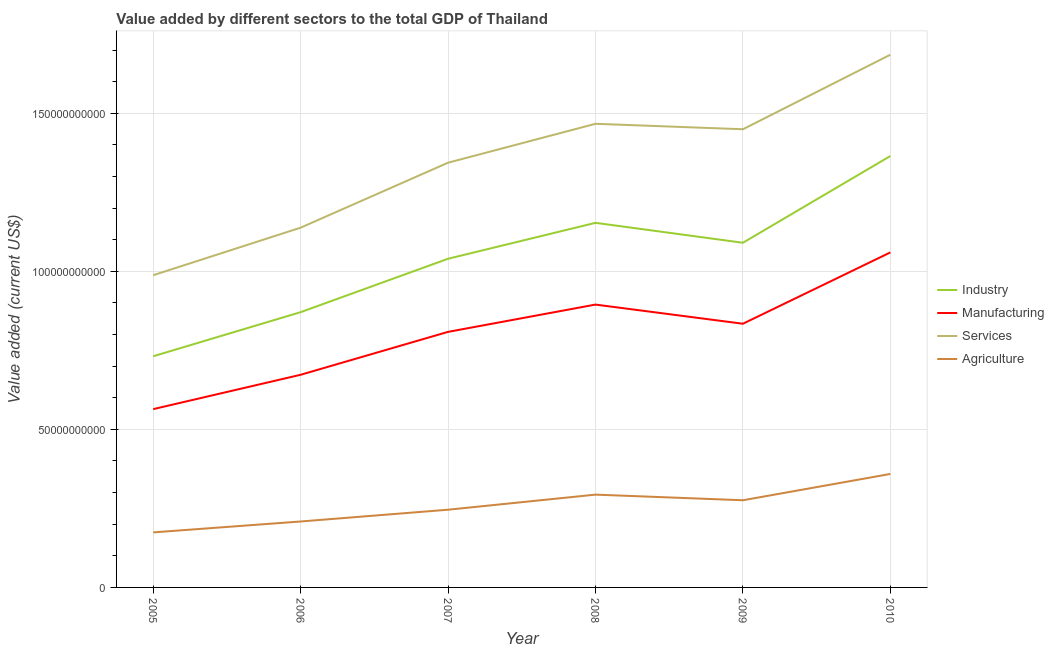How many different coloured lines are there?
Offer a very short reply. 4. Does the line corresponding to value added by industrial sector intersect with the line corresponding to value added by services sector?
Your answer should be compact. No. What is the value added by services sector in 2009?
Keep it short and to the point. 1.45e+11. Across all years, what is the maximum value added by industrial sector?
Give a very brief answer. 1.36e+11. Across all years, what is the minimum value added by industrial sector?
Provide a succinct answer. 7.31e+1. What is the total value added by services sector in the graph?
Your answer should be very brief. 8.07e+11. What is the difference between the value added by manufacturing sector in 2006 and that in 2008?
Provide a short and direct response. -2.22e+1. What is the difference between the value added by manufacturing sector in 2009 and the value added by industrial sector in 2007?
Provide a succinct answer. -2.06e+1. What is the average value added by industrial sector per year?
Provide a short and direct response. 1.04e+11. In the year 2008, what is the difference between the value added by agricultural sector and value added by services sector?
Ensure brevity in your answer.  -1.17e+11. What is the ratio of the value added by agricultural sector in 2006 to that in 2010?
Offer a terse response. 0.58. Is the value added by services sector in 2005 less than that in 2008?
Give a very brief answer. Yes. Is the difference between the value added by manufacturing sector in 2006 and 2010 greater than the difference between the value added by industrial sector in 2006 and 2010?
Your response must be concise. Yes. What is the difference between the highest and the second highest value added by manufacturing sector?
Give a very brief answer. 1.65e+1. What is the difference between the highest and the lowest value added by agricultural sector?
Offer a very short reply. 1.85e+1. Is it the case that in every year, the sum of the value added by services sector and value added by agricultural sector is greater than the sum of value added by manufacturing sector and value added by industrial sector?
Ensure brevity in your answer.  No. Is the value added by agricultural sector strictly less than the value added by services sector over the years?
Your answer should be compact. Yes. How many lines are there?
Ensure brevity in your answer.  4. How many years are there in the graph?
Provide a succinct answer. 6. Does the graph contain grids?
Provide a succinct answer. Yes. How many legend labels are there?
Make the answer very short. 4. How are the legend labels stacked?
Keep it short and to the point. Vertical. What is the title of the graph?
Your response must be concise. Value added by different sectors to the total GDP of Thailand. Does "Denmark" appear as one of the legend labels in the graph?
Your answer should be compact. No. What is the label or title of the X-axis?
Keep it short and to the point. Year. What is the label or title of the Y-axis?
Offer a very short reply. Value added (current US$). What is the Value added (current US$) in Industry in 2005?
Your answer should be compact. 7.31e+1. What is the Value added (current US$) of Manufacturing in 2005?
Your answer should be compact. 5.64e+1. What is the Value added (current US$) in Services in 2005?
Offer a very short reply. 9.88e+1. What is the Value added (current US$) in Agriculture in 2005?
Make the answer very short. 1.74e+1. What is the Value added (current US$) of Industry in 2006?
Offer a very short reply. 8.71e+1. What is the Value added (current US$) of Manufacturing in 2006?
Ensure brevity in your answer.  6.73e+1. What is the Value added (current US$) of Services in 2006?
Make the answer very short. 1.14e+11. What is the Value added (current US$) in Agriculture in 2006?
Offer a very short reply. 2.09e+1. What is the Value added (current US$) in Industry in 2007?
Offer a very short reply. 1.04e+11. What is the Value added (current US$) of Manufacturing in 2007?
Your response must be concise. 8.08e+1. What is the Value added (current US$) in Services in 2007?
Your response must be concise. 1.34e+11. What is the Value added (current US$) in Agriculture in 2007?
Offer a terse response. 2.46e+1. What is the Value added (current US$) in Industry in 2008?
Offer a very short reply. 1.15e+11. What is the Value added (current US$) of Manufacturing in 2008?
Your response must be concise. 8.95e+1. What is the Value added (current US$) in Services in 2008?
Give a very brief answer. 1.47e+11. What is the Value added (current US$) of Agriculture in 2008?
Offer a very short reply. 2.94e+1. What is the Value added (current US$) of Industry in 2009?
Provide a short and direct response. 1.09e+11. What is the Value added (current US$) of Manufacturing in 2009?
Make the answer very short. 8.34e+1. What is the Value added (current US$) in Services in 2009?
Offer a terse response. 1.45e+11. What is the Value added (current US$) of Agriculture in 2009?
Keep it short and to the point. 2.76e+1. What is the Value added (current US$) of Industry in 2010?
Offer a very short reply. 1.36e+11. What is the Value added (current US$) of Manufacturing in 2010?
Offer a very short reply. 1.06e+11. What is the Value added (current US$) in Services in 2010?
Your response must be concise. 1.69e+11. What is the Value added (current US$) of Agriculture in 2010?
Offer a terse response. 3.59e+1. Across all years, what is the maximum Value added (current US$) of Industry?
Offer a terse response. 1.36e+11. Across all years, what is the maximum Value added (current US$) in Manufacturing?
Provide a short and direct response. 1.06e+11. Across all years, what is the maximum Value added (current US$) in Services?
Offer a terse response. 1.69e+11. Across all years, what is the maximum Value added (current US$) in Agriculture?
Make the answer very short. 3.59e+1. Across all years, what is the minimum Value added (current US$) in Industry?
Provide a succinct answer. 7.31e+1. Across all years, what is the minimum Value added (current US$) of Manufacturing?
Keep it short and to the point. 5.64e+1. Across all years, what is the minimum Value added (current US$) in Services?
Keep it short and to the point. 9.88e+1. Across all years, what is the minimum Value added (current US$) of Agriculture?
Offer a terse response. 1.74e+1. What is the total Value added (current US$) in Industry in the graph?
Offer a very short reply. 6.25e+11. What is the total Value added (current US$) of Manufacturing in the graph?
Provide a short and direct response. 4.83e+11. What is the total Value added (current US$) of Services in the graph?
Your answer should be compact. 8.07e+11. What is the total Value added (current US$) in Agriculture in the graph?
Give a very brief answer. 1.56e+11. What is the difference between the Value added (current US$) of Industry in 2005 and that in 2006?
Offer a terse response. -1.40e+1. What is the difference between the Value added (current US$) of Manufacturing in 2005 and that in 2006?
Your answer should be very brief. -1.09e+1. What is the difference between the Value added (current US$) of Services in 2005 and that in 2006?
Keep it short and to the point. -1.50e+1. What is the difference between the Value added (current US$) in Agriculture in 2005 and that in 2006?
Provide a short and direct response. -3.45e+09. What is the difference between the Value added (current US$) of Industry in 2005 and that in 2007?
Offer a very short reply. -3.09e+1. What is the difference between the Value added (current US$) of Manufacturing in 2005 and that in 2007?
Ensure brevity in your answer.  -2.44e+1. What is the difference between the Value added (current US$) of Services in 2005 and that in 2007?
Your answer should be very brief. -3.56e+1. What is the difference between the Value added (current US$) of Agriculture in 2005 and that in 2007?
Your answer should be very brief. -7.17e+09. What is the difference between the Value added (current US$) of Industry in 2005 and that in 2008?
Ensure brevity in your answer.  -4.22e+1. What is the difference between the Value added (current US$) in Manufacturing in 2005 and that in 2008?
Your response must be concise. -3.31e+1. What is the difference between the Value added (current US$) in Services in 2005 and that in 2008?
Keep it short and to the point. -4.79e+1. What is the difference between the Value added (current US$) of Agriculture in 2005 and that in 2008?
Provide a short and direct response. -1.19e+1. What is the difference between the Value added (current US$) of Industry in 2005 and that in 2009?
Provide a short and direct response. -3.59e+1. What is the difference between the Value added (current US$) in Manufacturing in 2005 and that in 2009?
Keep it short and to the point. -2.70e+1. What is the difference between the Value added (current US$) of Services in 2005 and that in 2009?
Offer a very short reply. -4.62e+1. What is the difference between the Value added (current US$) in Agriculture in 2005 and that in 2009?
Provide a short and direct response. -1.02e+1. What is the difference between the Value added (current US$) of Industry in 2005 and that in 2010?
Offer a very short reply. -6.34e+1. What is the difference between the Value added (current US$) of Manufacturing in 2005 and that in 2010?
Ensure brevity in your answer.  -4.96e+1. What is the difference between the Value added (current US$) of Services in 2005 and that in 2010?
Keep it short and to the point. -6.98e+1. What is the difference between the Value added (current US$) in Agriculture in 2005 and that in 2010?
Provide a succinct answer. -1.85e+1. What is the difference between the Value added (current US$) in Industry in 2006 and that in 2007?
Give a very brief answer. -1.69e+1. What is the difference between the Value added (current US$) in Manufacturing in 2006 and that in 2007?
Your answer should be very brief. -1.36e+1. What is the difference between the Value added (current US$) in Services in 2006 and that in 2007?
Provide a short and direct response. -2.06e+1. What is the difference between the Value added (current US$) of Agriculture in 2006 and that in 2007?
Your answer should be very brief. -3.73e+09. What is the difference between the Value added (current US$) in Industry in 2006 and that in 2008?
Make the answer very short. -2.83e+1. What is the difference between the Value added (current US$) of Manufacturing in 2006 and that in 2008?
Your answer should be very brief. -2.22e+1. What is the difference between the Value added (current US$) of Services in 2006 and that in 2008?
Make the answer very short. -3.29e+1. What is the difference between the Value added (current US$) in Agriculture in 2006 and that in 2008?
Your answer should be compact. -8.50e+09. What is the difference between the Value added (current US$) of Industry in 2006 and that in 2009?
Make the answer very short. -2.20e+1. What is the difference between the Value added (current US$) in Manufacturing in 2006 and that in 2009?
Your answer should be very brief. -1.61e+1. What is the difference between the Value added (current US$) of Services in 2006 and that in 2009?
Make the answer very short. -3.11e+1. What is the difference between the Value added (current US$) of Agriculture in 2006 and that in 2009?
Keep it short and to the point. -6.72e+09. What is the difference between the Value added (current US$) in Industry in 2006 and that in 2010?
Your answer should be very brief. -4.94e+1. What is the difference between the Value added (current US$) in Manufacturing in 2006 and that in 2010?
Offer a terse response. -3.87e+1. What is the difference between the Value added (current US$) of Services in 2006 and that in 2010?
Your answer should be very brief. -5.47e+1. What is the difference between the Value added (current US$) in Agriculture in 2006 and that in 2010?
Provide a short and direct response. -1.50e+1. What is the difference between the Value added (current US$) in Industry in 2007 and that in 2008?
Your answer should be very brief. -1.14e+1. What is the difference between the Value added (current US$) of Manufacturing in 2007 and that in 2008?
Make the answer very short. -8.63e+09. What is the difference between the Value added (current US$) of Services in 2007 and that in 2008?
Your answer should be compact. -1.23e+1. What is the difference between the Value added (current US$) in Agriculture in 2007 and that in 2008?
Make the answer very short. -4.77e+09. What is the difference between the Value added (current US$) in Industry in 2007 and that in 2009?
Make the answer very short. -5.06e+09. What is the difference between the Value added (current US$) in Manufacturing in 2007 and that in 2009?
Make the answer very short. -2.57e+09. What is the difference between the Value added (current US$) in Services in 2007 and that in 2009?
Your answer should be very brief. -1.06e+1. What is the difference between the Value added (current US$) of Agriculture in 2007 and that in 2009?
Offer a very short reply. -2.99e+09. What is the difference between the Value added (current US$) in Industry in 2007 and that in 2010?
Your answer should be compact. -3.25e+1. What is the difference between the Value added (current US$) of Manufacturing in 2007 and that in 2010?
Your answer should be very brief. -2.51e+1. What is the difference between the Value added (current US$) of Services in 2007 and that in 2010?
Your response must be concise. -3.42e+1. What is the difference between the Value added (current US$) of Agriculture in 2007 and that in 2010?
Your answer should be compact. -1.13e+1. What is the difference between the Value added (current US$) in Industry in 2008 and that in 2009?
Ensure brevity in your answer.  6.30e+09. What is the difference between the Value added (current US$) in Manufacturing in 2008 and that in 2009?
Give a very brief answer. 6.06e+09. What is the difference between the Value added (current US$) of Services in 2008 and that in 2009?
Give a very brief answer. 1.73e+09. What is the difference between the Value added (current US$) in Agriculture in 2008 and that in 2009?
Make the answer very short. 1.78e+09. What is the difference between the Value added (current US$) of Industry in 2008 and that in 2010?
Make the answer very short. -2.11e+1. What is the difference between the Value added (current US$) in Manufacturing in 2008 and that in 2010?
Give a very brief answer. -1.65e+1. What is the difference between the Value added (current US$) in Services in 2008 and that in 2010?
Ensure brevity in your answer.  -2.19e+1. What is the difference between the Value added (current US$) of Agriculture in 2008 and that in 2010?
Offer a very short reply. -6.54e+09. What is the difference between the Value added (current US$) in Industry in 2009 and that in 2010?
Your answer should be very brief. -2.74e+1. What is the difference between the Value added (current US$) of Manufacturing in 2009 and that in 2010?
Make the answer very short. -2.26e+1. What is the difference between the Value added (current US$) in Services in 2009 and that in 2010?
Make the answer very short. -2.36e+1. What is the difference between the Value added (current US$) of Agriculture in 2009 and that in 2010?
Make the answer very short. -8.32e+09. What is the difference between the Value added (current US$) in Industry in 2005 and the Value added (current US$) in Manufacturing in 2006?
Your answer should be compact. 5.86e+09. What is the difference between the Value added (current US$) of Industry in 2005 and the Value added (current US$) of Services in 2006?
Keep it short and to the point. -4.07e+1. What is the difference between the Value added (current US$) of Industry in 2005 and the Value added (current US$) of Agriculture in 2006?
Provide a succinct answer. 5.23e+1. What is the difference between the Value added (current US$) in Manufacturing in 2005 and the Value added (current US$) in Services in 2006?
Provide a succinct answer. -5.74e+1. What is the difference between the Value added (current US$) of Manufacturing in 2005 and the Value added (current US$) of Agriculture in 2006?
Ensure brevity in your answer.  3.55e+1. What is the difference between the Value added (current US$) in Services in 2005 and the Value added (current US$) in Agriculture in 2006?
Offer a very short reply. 7.79e+1. What is the difference between the Value added (current US$) of Industry in 2005 and the Value added (current US$) of Manufacturing in 2007?
Give a very brief answer. -7.72e+09. What is the difference between the Value added (current US$) in Industry in 2005 and the Value added (current US$) in Services in 2007?
Provide a succinct answer. -6.12e+1. What is the difference between the Value added (current US$) in Industry in 2005 and the Value added (current US$) in Agriculture in 2007?
Offer a terse response. 4.85e+1. What is the difference between the Value added (current US$) in Manufacturing in 2005 and the Value added (current US$) in Services in 2007?
Make the answer very short. -7.80e+1. What is the difference between the Value added (current US$) of Manufacturing in 2005 and the Value added (current US$) of Agriculture in 2007?
Keep it short and to the point. 3.18e+1. What is the difference between the Value added (current US$) in Services in 2005 and the Value added (current US$) in Agriculture in 2007?
Make the answer very short. 7.42e+1. What is the difference between the Value added (current US$) in Industry in 2005 and the Value added (current US$) in Manufacturing in 2008?
Provide a short and direct response. -1.64e+1. What is the difference between the Value added (current US$) of Industry in 2005 and the Value added (current US$) of Services in 2008?
Your response must be concise. -7.35e+1. What is the difference between the Value added (current US$) of Industry in 2005 and the Value added (current US$) of Agriculture in 2008?
Your response must be concise. 4.38e+1. What is the difference between the Value added (current US$) in Manufacturing in 2005 and the Value added (current US$) in Services in 2008?
Provide a short and direct response. -9.03e+1. What is the difference between the Value added (current US$) in Manufacturing in 2005 and the Value added (current US$) in Agriculture in 2008?
Your answer should be very brief. 2.70e+1. What is the difference between the Value added (current US$) of Services in 2005 and the Value added (current US$) of Agriculture in 2008?
Provide a short and direct response. 6.94e+1. What is the difference between the Value added (current US$) in Industry in 2005 and the Value added (current US$) in Manufacturing in 2009?
Give a very brief answer. -1.03e+1. What is the difference between the Value added (current US$) in Industry in 2005 and the Value added (current US$) in Services in 2009?
Your response must be concise. -7.18e+1. What is the difference between the Value added (current US$) of Industry in 2005 and the Value added (current US$) of Agriculture in 2009?
Ensure brevity in your answer.  4.56e+1. What is the difference between the Value added (current US$) of Manufacturing in 2005 and the Value added (current US$) of Services in 2009?
Provide a short and direct response. -8.85e+1. What is the difference between the Value added (current US$) in Manufacturing in 2005 and the Value added (current US$) in Agriculture in 2009?
Keep it short and to the point. 2.88e+1. What is the difference between the Value added (current US$) of Services in 2005 and the Value added (current US$) of Agriculture in 2009?
Your response must be concise. 7.12e+1. What is the difference between the Value added (current US$) in Industry in 2005 and the Value added (current US$) in Manufacturing in 2010?
Keep it short and to the point. -3.29e+1. What is the difference between the Value added (current US$) in Industry in 2005 and the Value added (current US$) in Services in 2010?
Offer a terse response. -9.54e+1. What is the difference between the Value added (current US$) in Industry in 2005 and the Value added (current US$) in Agriculture in 2010?
Keep it short and to the point. 3.72e+1. What is the difference between the Value added (current US$) in Manufacturing in 2005 and the Value added (current US$) in Services in 2010?
Offer a very short reply. -1.12e+11. What is the difference between the Value added (current US$) in Manufacturing in 2005 and the Value added (current US$) in Agriculture in 2010?
Offer a very short reply. 2.05e+1. What is the difference between the Value added (current US$) in Services in 2005 and the Value added (current US$) in Agriculture in 2010?
Your answer should be compact. 6.29e+1. What is the difference between the Value added (current US$) in Industry in 2006 and the Value added (current US$) in Manufacturing in 2007?
Ensure brevity in your answer.  6.23e+09. What is the difference between the Value added (current US$) in Industry in 2006 and the Value added (current US$) in Services in 2007?
Offer a terse response. -4.73e+1. What is the difference between the Value added (current US$) in Industry in 2006 and the Value added (current US$) in Agriculture in 2007?
Provide a short and direct response. 6.25e+1. What is the difference between the Value added (current US$) of Manufacturing in 2006 and the Value added (current US$) of Services in 2007?
Ensure brevity in your answer.  -6.71e+1. What is the difference between the Value added (current US$) in Manufacturing in 2006 and the Value added (current US$) in Agriculture in 2007?
Provide a succinct answer. 4.27e+1. What is the difference between the Value added (current US$) of Services in 2006 and the Value added (current US$) of Agriculture in 2007?
Provide a short and direct response. 8.92e+1. What is the difference between the Value added (current US$) of Industry in 2006 and the Value added (current US$) of Manufacturing in 2008?
Provide a succinct answer. -2.40e+09. What is the difference between the Value added (current US$) of Industry in 2006 and the Value added (current US$) of Services in 2008?
Your answer should be very brief. -5.96e+1. What is the difference between the Value added (current US$) in Industry in 2006 and the Value added (current US$) in Agriculture in 2008?
Provide a succinct answer. 5.77e+1. What is the difference between the Value added (current US$) of Manufacturing in 2006 and the Value added (current US$) of Services in 2008?
Your answer should be compact. -7.94e+1. What is the difference between the Value added (current US$) in Manufacturing in 2006 and the Value added (current US$) in Agriculture in 2008?
Offer a very short reply. 3.79e+1. What is the difference between the Value added (current US$) in Services in 2006 and the Value added (current US$) in Agriculture in 2008?
Ensure brevity in your answer.  8.45e+1. What is the difference between the Value added (current US$) in Industry in 2006 and the Value added (current US$) in Manufacturing in 2009?
Ensure brevity in your answer.  3.66e+09. What is the difference between the Value added (current US$) of Industry in 2006 and the Value added (current US$) of Services in 2009?
Your response must be concise. -5.79e+1. What is the difference between the Value added (current US$) of Industry in 2006 and the Value added (current US$) of Agriculture in 2009?
Make the answer very short. 5.95e+1. What is the difference between the Value added (current US$) in Manufacturing in 2006 and the Value added (current US$) in Services in 2009?
Make the answer very short. -7.77e+1. What is the difference between the Value added (current US$) of Manufacturing in 2006 and the Value added (current US$) of Agriculture in 2009?
Your answer should be compact. 3.97e+1. What is the difference between the Value added (current US$) in Services in 2006 and the Value added (current US$) in Agriculture in 2009?
Make the answer very short. 8.62e+1. What is the difference between the Value added (current US$) of Industry in 2006 and the Value added (current US$) of Manufacturing in 2010?
Make the answer very short. -1.89e+1. What is the difference between the Value added (current US$) of Industry in 2006 and the Value added (current US$) of Services in 2010?
Ensure brevity in your answer.  -8.15e+1. What is the difference between the Value added (current US$) in Industry in 2006 and the Value added (current US$) in Agriculture in 2010?
Your response must be concise. 5.12e+1. What is the difference between the Value added (current US$) in Manufacturing in 2006 and the Value added (current US$) in Services in 2010?
Your answer should be compact. -1.01e+11. What is the difference between the Value added (current US$) in Manufacturing in 2006 and the Value added (current US$) in Agriculture in 2010?
Offer a terse response. 3.14e+1. What is the difference between the Value added (current US$) in Services in 2006 and the Value added (current US$) in Agriculture in 2010?
Provide a succinct answer. 7.79e+1. What is the difference between the Value added (current US$) of Industry in 2007 and the Value added (current US$) of Manufacturing in 2008?
Offer a very short reply. 1.45e+1. What is the difference between the Value added (current US$) in Industry in 2007 and the Value added (current US$) in Services in 2008?
Your answer should be compact. -4.27e+1. What is the difference between the Value added (current US$) in Industry in 2007 and the Value added (current US$) in Agriculture in 2008?
Give a very brief answer. 7.46e+1. What is the difference between the Value added (current US$) of Manufacturing in 2007 and the Value added (current US$) of Services in 2008?
Your answer should be compact. -6.58e+1. What is the difference between the Value added (current US$) in Manufacturing in 2007 and the Value added (current US$) in Agriculture in 2008?
Provide a short and direct response. 5.15e+1. What is the difference between the Value added (current US$) of Services in 2007 and the Value added (current US$) of Agriculture in 2008?
Give a very brief answer. 1.05e+11. What is the difference between the Value added (current US$) in Industry in 2007 and the Value added (current US$) in Manufacturing in 2009?
Make the answer very short. 2.06e+1. What is the difference between the Value added (current US$) of Industry in 2007 and the Value added (current US$) of Services in 2009?
Provide a short and direct response. -4.10e+1. What is the difference between the Value added (current US$) of Industry in 2007 and the Value added (current US$) of Agriculture in 2009?
Make the answer very short. 7.64e+1. What is the difference between the Value added (current US$) of Manufacturing in 2007 and the Value added (current US$) of Services in 2009?
Provide a short and direct response. -6.41e+1. What is the difference between the Value added (current US$) of Manufacturing in 2007 and the Value added (current US$) of Agriculture in 2009?
Your answer should be compact. 5.33e+1. What is the difference between the Value added (current US$) of Services in 2007 and the Value added (current US$) of Agriculture in 2009?
Offer a very short reply. 1.07e+11. What is the difference between the Value added (current US$) in Industry in 2007 and the Value added (current US$) in Manufacturing in 2010?
Give a very brief answer. -2.00e+09. What is the difference between the Value added (current US$) in Industry in 2007 and the Value added (current US$) in Services in 2010?
Provide a succinct answer. -6.46e+1. What is the difference between the Value added (current US$) in Industry in 2007 and the Value added (current US$) in Agriculture in 2010?
Keep it short and to the point. 6.81e+1. What is the difference between the Value added (current US$) of Manufacturing in 2007 and the Value added (current US$) of Services in 2010?
Provide a short and direct response. -8.77e+1. What is the difference between the Value added (current US$) in Manufacturing in 2007 and the Value added (current US$) in Agriculture in 2010?
Ensure brevity in your answer.  4.49e+1. What is the difference between the Value added (current US$) in Services in 2007 and the Value added (current US$) in Agriculture in 2010?
Give a very brief answer. 9.85e+1. What is the difference between the Value added (current US$) in Industry in 2008 and the Value added (current US$) in Manufacturing in 2009?
Offer a terse response. 3.19e+1. What is the difference between the Value added (current US$) in Industry in 2008 and the Value added (current US$) in Services in 2009?
Provide a succinct answer. -2.96e+1. What is the difference between the Value added (current US$) in Industry in 2008 and the Value added (current US$) in Agriculture in 2009?
Your response must be concise. 8.78e+1. What is the difference between the Value added (current US$) in Manufacturing in 2008 and the Value added (current US$) in Services in 2009?
Offer a very short reply. -5.55e+1. What is the difference between the Value added (current US$) of Manufacturing in 2008 and the Value added (current US$) of Agriculture in 2009?
Offer a terse response. 6.19e+1. What is the difference between the Value added (current US$) of Services in 2008 and the Value added (current US$) of Agriculture in 2009?
Offer a very short reply. 1.19e+11. What is the difference between the Value added (current US$) of Industry in 2008 and the Value added (current US$) of Manufacturing in 2010?
Your response must be concise. 9.36e+09. What is the difference between the Value added (current US$) of Industry in 2008 and the Value added (current US$) of Services in 2010?
Offer a terse response. -5.32e+1. What is the difference between the Value added (current US$) of Industry in 2008 and the Value added (current US$) of Agriculture in 2010?
Your answer should be very brief. 7.94e+1. What is the difference between the Value added (current US$) in Manufacturing in 2008 and the Value added (current US$) in Services in 2010?
Provide a succinct answer. -7.91e+1. What is the difference between the Value added (current US$) of Manufacturing in 2008 and the Value added (current US$) of Agriculture in 2010?
Ensure brevity in your answer.  5.36e+1. What is the difference between the Value added (current US$) in Services in 2008 and the Value added (current US$) in Agriculture in 2010?
Provide a short and direct response. 1.11e+11. What is the difference between the Value added (current US$) in Industry in 2009 and the Value added (current US$) in Manufacturing in 2010?
Provide a short and direct response. 3.06e+09. What is the difference between the Value added (current US$) of Industry in 2009 and the Value added (current US$) of Services in 2010?
Make the answer very short. -5.95e+1. What is the difference between the Value added (current US$) of Industry in 2009 and the Value added (current US$) of Agriculture in 2010?
Provide a short and direct response. 7.31e+1. What is the difference between the Value added (current US$) of Manufacturing in 2009 and the Value added (current US$) of Services in 2010?
Keep it short and to the point. -8.51e+1. What is the difference between the Value added (current US$) of Manufacturing in 2009 and the Value added (current US$) of Agriculture in 2010?
Keep it short and to the point. 4.75e+1. What is the difference between the Value added (current US$) in Services in 2009 and the Value added (current US$) in Agriculture in 2010?
Provide a succinct answer. 1.09e+11. What is the average Value added (current US$) of Industry per year?
Your response must be concise. 1.04e+11. What is the average Value added (current US$) of Manufacturing per year?
Your answer should be very brief. 8.06e+1. What is the average Value added (current US$) of Services per year?
Give a very brief answer. 1.35e+11. What is the average Value added (current US$) of Agriculture per year?
Provide a succinct answer. 2.59e+1. In the year 2005, what is the difference between the Value added (current US$) of Industry and Value added (current US$) of Manufacturing?
Your response must be concise. 1.67e+1. In the year 2005, what is the difference between the Value added (current US$) in Industry and Value added (current US$) in Services?
Provide a succinct answer. -2.56e+1. In the year 2005, what is the difference between the Value added (current US$) of Industry and Value added (current US$) of Agriculture?
Offer a very short reply. 5.57e+1. In the year 2005, what is the difference between the Value added (current US$) of Manufacturing and Value added (current US$) of Services?
Offer a very short reply. -4.24e+1. In the year 2005, what is the difference between the Value added (current US$) in Manufacturing and Value added (current US$) in Agriculture?
Provide a succinct answer. 3.90e+1. In the year 2005, what is the difference between the Value added (current US$) in Services and Value added (current US$) in Agriculture?
Your answer should be very brief. 8.14e+1. In the year 2006, what is the difference between the Value added (current US$) of Industry and Value added (current US$) of Manufacturing?
Give a very brief answer. 1.98e+1. In the year 2006, what is the difference between the Value added (current US$) of Industry and Value added (current US$) of Services?
Keep it short and to the point. -2.67e+1. In the year 2006, what is the difference between the Value added (current US$) of Industry and Value added (current US$) of Agriculture?
Your answer should be compact. 6.62e+1. In the year 2006, what is the difference between the Value added (current US$) of Manufacturing and Value added (current US$) of Services?
Give a very brief answer. -4.65e+1. In the year 2006, what is the difference between the Value added (current US$) of Manufacturing and Value added (current US$) of Agriculture?
Ensure brevity in your answer.  4.64e+1. In the year 2006, what is the difference between the Value added (current US$) in Services and Value added (current US$) in Agriculture?
Ensure brevity in your answer.  9.30e+1. In the year 2007, what is the difference between the Value added (current US$) in Industry and Value added (current US$) in Manufacturing?
Offer a terse response. 2.31e+1. In the year 2007, what is the difference between the Value added (current US$) of Industry and Value added (current US$) of Services?
Offer a terse response. -3.04e+1. In the year 2007, what is the difference between the Value added (current US$) in Industry and Value added (current US$) in Agriculture?
Make the answer very short. 7.94e+1. In the year 2007, what is the difference between the Value added (current US$) of Manufacturing and Value added (current US$) of Services?
Your answer should be very brief. -5.35e+1. In the year 2007, what is the difference between the Value added (current US$) of Manufacturing and Value added (current US$) of Agriculture?
Your answer should be compact. 5.63e+1. In the year 2007, what is the difference between the Value added (current US$) in Services and Value added (current US$) in Agriculture?
Ensure brevity in your answer.  1.10e+11. In the year 2008, what is the difference between the Value added (current US$) of Industry and Value added (current US$) of Manufacturing?
Keep it short and to the point. 2.59e+1. In the year 2008, what is the difference between the Value added (current US$) in Industry and Value added (current US$) in Services?
Your answer should be very brief. -3.13e+1. In the year 2008, what is the difference between the Value added (current US$) in Industry and Value added (current US$) in Agriculture?
Your answer should be very brief. 8.60e+1. In the year 2008, what is the difference between the Value added (current US$) in Manufacturing and Value added (current US$) in Services?
Your response must be concise. -5.72e+1. In the year 2008, what is the difference between the Value added (current US$) of Manufacturing and Value added (current US$) of Agriculture?
Ensure brevity in your answer.  6.01e+1. In the year 2008, what is the difference between the Value added (current US$) of Services and Value added (current US$) of Agriculture?
Make the answer very short. 1.17e+11. In the year 2009, what is the difference between the Value added (current US$) of Industry and Value added (current US$) of Manufacturing?
Your answer should be compact. 2.56e+1. In the year 2009, what is the difference between the Value added (current US$) in Industry and Value added (current US$) in Services?
Offer a very short reply. -3.59e+1. In the year 2009, what is the difference between the Value added (current US$) in Industry and Value added (current US$) in Agriculture?
Your response must be concise. 8.15e+1. In the year 2009, what is the difference between the Value added (current US$) in Manufacturing and Value added (current US$) in Services?
Offer a terse response. -6.15e+1. In the year 2009, what is the difference between the Value added (current US$) of Manufacturing and Value added (current US$) of Agriculture?
Your answer should be compact. 5.58e+1. In the year 2009, what is the difference between the Value added (current US$) in Services and Value added (current US$) in Agriculture?
Provide a succinct answer. 1.17e+11. In the year 2010, what is the difference between the Value added (current US$) in Industry and Value added (current US$) in Manufacturing?
Provide a short and direct response. 3.05e+1. In the year 2010, what is the difference between the Value added (current US$) in Industry and Value added (current US$) in Services?
Ensure brevity in your answer.  -3.21e+1. In the year 2010, what is the difference between the Value added (current US$) of Industry and Value added (current US$) of Agriculture?
Provide a short and direct response. 1.01e+11. In the year 2010, what is the difference between the Value added (current US$) in Manufacturing and Value added (current US$) in Services?
Offer a very short reply. -6.25e+1. In the year 2010, what is the difference between the Value added (current US$) in Manufacturing and Value added (current US$) in Agriculture?
Ensure brevity in your answer.  7.01e+1. In the year 2010, what is the difference between the Value added (current US$) of Services and Value added (current US$) of Agriculture?
Keep it short and to the point. 1.33e+11. What is the ratio of the Value added (current US$) in Industry in 2005 to that in 2006?
Your answer should be compact. 0.84. What is the ratio of the Value added (current US$) of Manufacturing in 2005 to that in 2006?
Give a very brief answer. 0.84. What is the ratio of the Value added (current US$) in Services in 2005 to that in 2006?
Offer a terse response. 0.87. What is the ratio of the Value added (current US$) in Agriculture in 2005 to that in 2006?
Ensure brevity in your answer.  0.83. What is the ratio of the Value added (current US$) in Industry in 2005 to that in 2007?
Your response must be concise. 0.7. What is the ratio of the Value added (current US$) in Manufacturing in 2005 to that in 2007?
Make the answer very short. 0.7. What is the ratio of the Value added (current US$) in Services in 2005 to that in 2007?
Your answer should be compact. 0.74. What is the ratio of the Value added (current US$) of Agriculture in 2005 to that in 2007?
Your response must be concise. 0.71. What is the ratio of the Value added (current US$) of Industry in 2005 to that in 2008?
Make the answer very short. 0.63. What is the ratio of the Value added (current US$) of Manufacturing in 2005 to that in 2008?
Your answer should be very brief. 0.63. What is the ratio of the Value added (current US$) in Services in 2005 to that in 2008?
Offer a terse response. 0.67. What is the ratio of the Value added (current US$) in Agriculture in 2005 to that in 2008?
Provide a succinct answer. 0.59. What is the ratio of the Value added (current US$) of Industry in 2005 to that in 2009?
Provide a short and direct response. 0.67. What is the ratio of the Value added (current US$) in Manufacturing in 2005 to that in 2009?
Your answer should be compact. 0.68. What is the ratio of the Value added (current US$) in Services in 2005 to that in 2009?
Keep it short and to the point. 0.68. What is the ratio of the Value added (current US$) of Agriculture in 2005 to that in 2009?
Make the answer very short. 0.63. What is the ratio of the Value added (current US$) in Industry in 2005 to that in 2010?
Your response must be concise. 0.54. What is the ratio of the Value added (current US$) in Manufacturing in 2005 to that in 2010?
Give a very brief answer. 0.53. What is the ratio of the Value added (current US$) in Services in 2005 to that in 2010?
Keep it short and to the point. 0.59. What is the ratio of the Value added (current US$) of Agriculture in 2005 to that in 2010?
Your answer should be compact. 0.48. What is the ratio of the Value added (current US$) in Industry in 2006 to that in 2007?
Your answer should be very brief. 0.84. What is the ratio of the Value added (current US$) in Manufacturing in 2006 to that in 2007?
Your answer should be compact. 0.83. What is the ratio of the Value added (current US$) in Services in 2006 to that in 2007?
Your answer should be compact. 0.85. What is the ratio of the Value added (current US$) in Agriculture in 2006 to that in 2007?
Give a very brief answer. 0.85. What is the ratio of the Value added (current US$) in Industry in 2006 to that in 2008?
Provide a succinct answer. 0.76. What is the ratio of the Value added (current US$) in Manufacturing in 2006 to that in 2008?
Offer a terse response. 0.75. What is the ratio of the Value added (current US$) in Services in 2006 to that in 2008?
Make the answer very short. 0.78. What is the ratio of the Value added (current US$) of Agriculture in 2006 to that in 2008?
Give a very brief answer. 0.71. What is the ratio of the Value added (current US$) in Industry in 2006 to that in 2009?
Make the answer very short. 0.8. What is the ratio of the Value added (current US$) in Manufacturing in 2006 to that in 2009?
Make the answer very short. 0.81. What is the ratio of the Value added (current US$) in Services in 2006 to that in 2009?
Provide a short and direct response. 0.79. What is the ratio of the Value added (current US$) of Agriculture in 2006 to that in 2009?
Your response must be concise. 0.76. What is the ratio of the Value added (current US$) in Industry in 2006 to that in 2010?
Give a very brief answer. 0.64. What is the ratio of the Value added (current US$) in Manufacturing in 2006 to that in 2010?
Your answer should be compact. 0.63. What is the ratio of the Value added (current US$) in Services in 2006 to that in 2010?
Make the answer very short. 0.68. What is the ratio of the Value added (current US$) in Agriculture in 2006 to that in 2010?
Offer a terse response. 0.58. What is the ratio of the Value added (current US$) of Industry in 2007 to that in 2008?
Make the answer very short. 0.9. What is the ratio of the Value added (current US$) in Manufacturing in 2007 to that in 2008?
Offer a very short reply. 0.9. What is the ratio of the Value added (current US$) in Services in 2007 to that in 2008?
Provide a succinct answer. 0.92. What is the ratio of the Value added (current US$) of Agriculture in 2007 to that in 2008?
Make the answer very short. 0.84. What is the ratio of the Value added (current US$) of Industry in 2007 to that in 2009?
Offer a very short reply. 0.95. What is the ratio of the Value added (current US$) in Manufacturing in 2007 to that in 2009?
Ensure brevity in your answer.  0.97. What is the ratio of the Value added (current US$) in Services in 2007 to that in 2009?
Give a very brief answer. 0.93. What is the ratio of the Value added (current US$) in Agriculture in 2007 to that in 2009?
Keep it short and to the point. 0.89. What is the ratio of the Value added (current US$) in Industry in 2007 to that in 2010?
Make the answer very short. 0.76. What is the ratio of the Value added (current US$) of Manufacturing in 2007 to that in 2010?
Provide a short and direct response. 0.76. What is the ratio of the Value added (current US$) of Services in 2007 to that in 2010?
Your answer should be very brief. 0.8. What is the ratio of the Value added (current US$) of Agriculture in 2007 to that in 2010?
Provide a succinct answer. 0.68. What is the ratio of the Value added (current US$) in Industry in 2008 to that in 2009?
Give a very brief answer. 1.06. What is the ratio of the Value added (current US$) of Manufacturing in 2008 to that in 2009?
Ensure brevity in your answer.  1.07. What is the ratio of the Value added (current US$) in Services in 2008 to that in 2009?
Offer a terse response. 1.01. What is the ratio of the Value added (current US$) of Agriculture in 2008 to that in 2009?
Provide a short and direct response. 1.06. What is the ratio of the Value added (current US$) of Industry in 2008 to that in 2010?
Ensure brevity in your answer.  0.85. What is the ratio of the Value added (current US$) in Manufacturing in 2008 to that in 2010?
Your answer should be compact. 0.84. What is the ratio of the Value added (current US$) in Services in 2008 to that in 2010?
Provide a succinct answer. 0.87. What is the ratio of the Value added (current US$) in Agriculture in 2008 to that in 2010?
Offer a very short reply. 0.82. What is the ratio of the Value added (current US$) in Industry in 2009 to that in 2010?
Provide a short and direct response. 0.8. What is the ratio of the Value added (current US$) in Manufacturing in 2009 to that in 2010?
Give a very brief answer. 0.79. What is the ratio of the Value added (current US$) in Services in 2009 to that in 2010?
Make the answer very short. 0.86. What is the ratio of the Value added (current US$) of Agriculture in 2009 to that in 2010?
Your answer should be compact. 0.77. What is the difference between the highest and the second highest Value added (current US$) of Industry?
Your answer should be very brief. 2.11e+1. What is the difference between the highest and the second highest Value added (current US$) of Manufacturing?
Offer a very short reply. 1.65e+1. What is the difference between the highest and the second highest Value added (current US$) in Services?
Make the answer very short. 2.19e+1. What is the difference between the highest and the second highest Value added (current US$) in Agriculture?
Your answer should be compact. 6.54e+09. What is the difference between the highest and the lowest Value added (current US$) in Industry?
Ensure brevity in your answer.  6.34e+1. What is the difference between the highest and the lowest Value added (current US$) of Manufacturing?
Provide a short and direct response. 4.96e+1. What is the difference between the highest and the lowest Value added (current US$) in Services?
Offer a very short reply. 6.98e+1. What is the difference between the highest and the lowest Value added (current US$) of Agriculture?
Offer a terse response. 1.85e+1. 